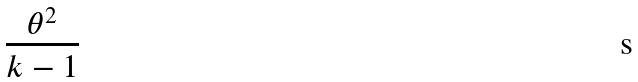Convert formula to latex. <formula><loc_0><loc_0><loc_500><loc_500>\frac { \theta ^ { 2 } } { k - 1 }</formula> 